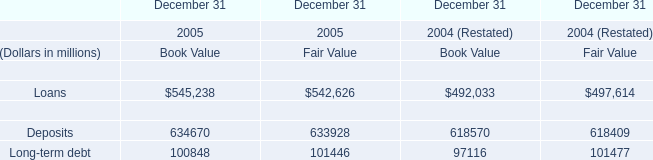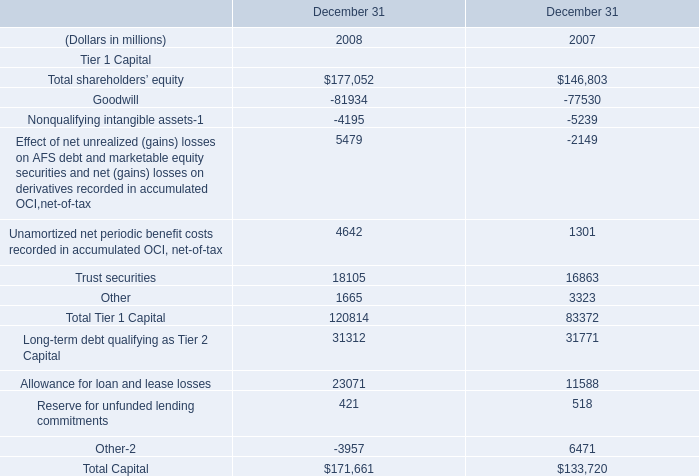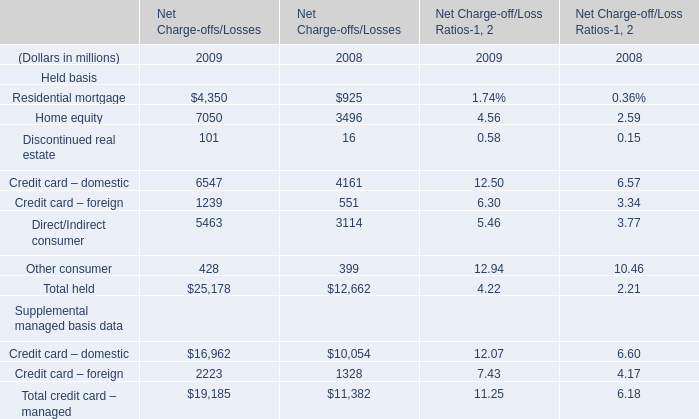What is the average value of Other consumer of Net Charge-offs/Losses in Table 2and Reserve for unfunded lending commitments in Table 1 in 2008? (in million) 
Computations: ((399 + 421) / 2)
Answer: 410.0. 